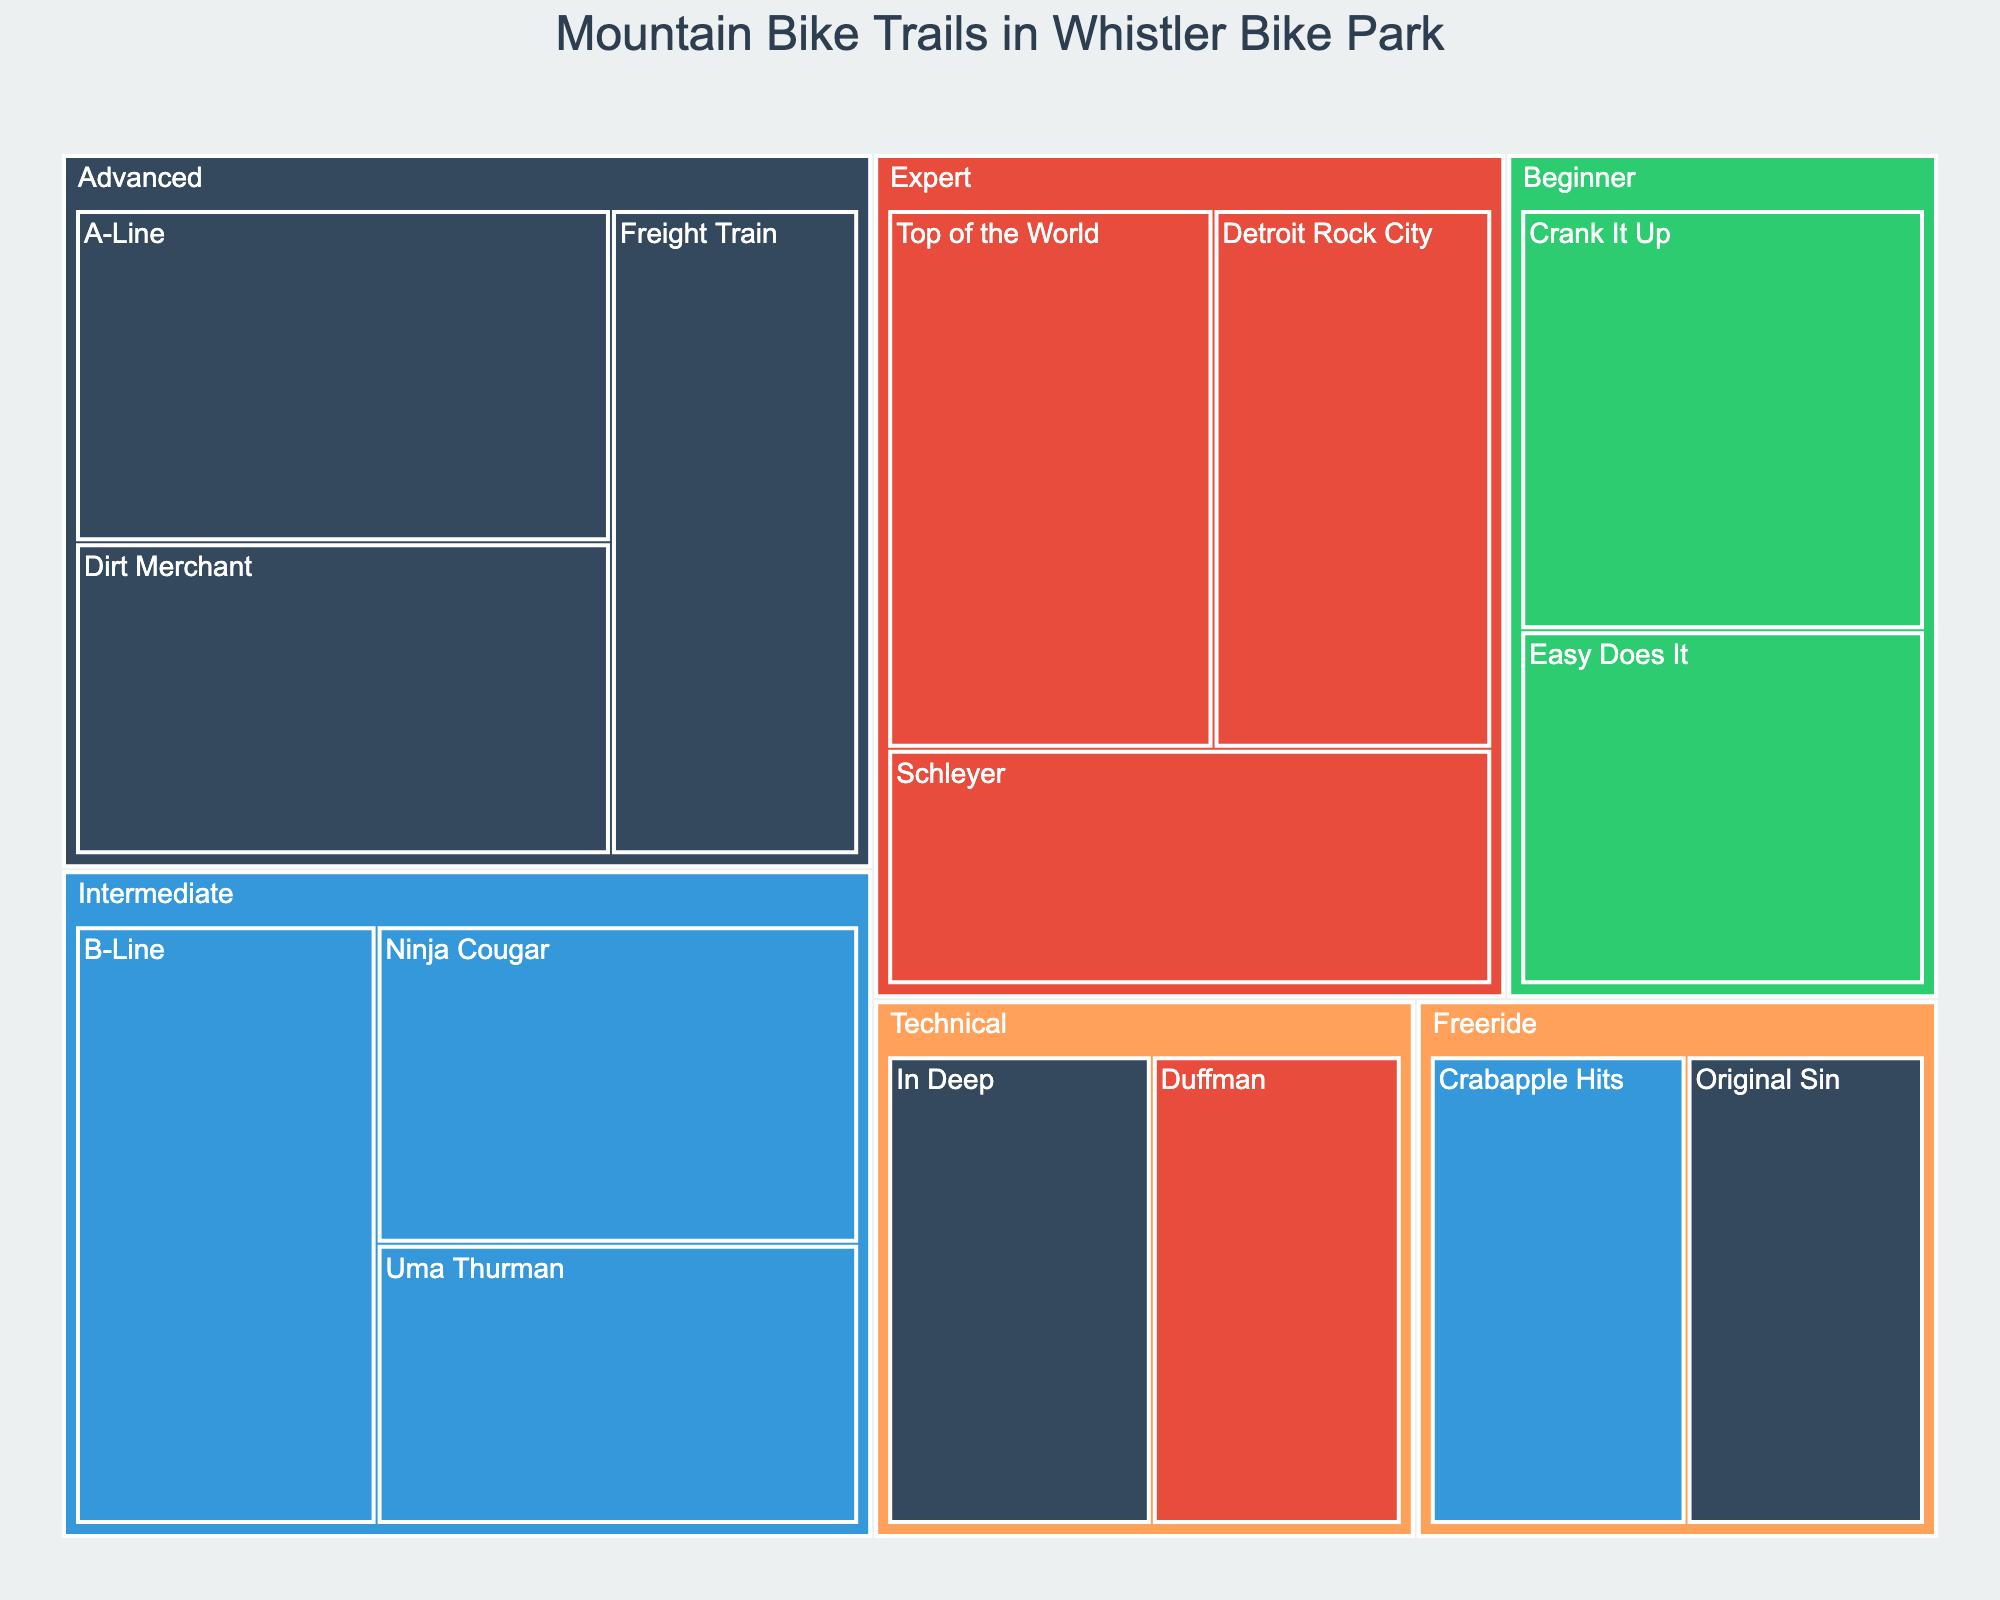How many different trail categories are shown in the treemap? Look at the distinct categories listed in the treemap, such as Beginner, Intermediate, Advanced, Expert, Freeride, and Technical. Count each one.
Answer: 6 Which trail within the Beginner category has the highest popularity? Focus on the Beginner category and then check the popularity values for each trail (Easy Does It and Crank It Up). Compare these values.
Answer: Crank It Up What is the combined popularity of all Advanced trails? Locate all trails under the Advanced category and sum their popularity values (A-Line, Dirt Merchant, Freight Train). 98 + 92 + 88 = 278
Answer: 278 Which trail has the lowest popularity and what is its category? Scan the treemap for the trail with the smallest popularity value and note its category. The lowest value here is 65 for Original Sin in the Freeride category.
Answer: Original Sin, Freeride Which difficulty level is associated with the Ninja Cougar trail? Find the trail named Ninja Cougar and check its color code, which represents the difficulty level.
Answer: Blue Is there any Double Black trail in the Freeride category? Examine the Freeride category and check the color codes of the trails listed there to see if any are Double Black.
Answer: No How many trails are classified under Intermediate category? Look for the Intermediate category and count the number of distinct trails within it.
Answer: 3 Which Expert trail has higher popularity, Top of the World or Schleyer? Within the Expert category, compare the popularity of the Top of the World and Schleyer trails.
Answer: Top of the World Compare the popularity of the most popular Green trail to the most popular Blue trail. Which one is higher? Identify the most popular Green trail (Crank It Up with 95) and the most popular Blue trail (B-Line with 100), then compare their popularity values.
Answer: B-Line is higher Calculate the average popularity of all trails in the Technical category. Locate all trails in the Technical category (In Deep and Duffman) and calculate their average popularity. (72 + 68)/2 = 70
Answer: 70 